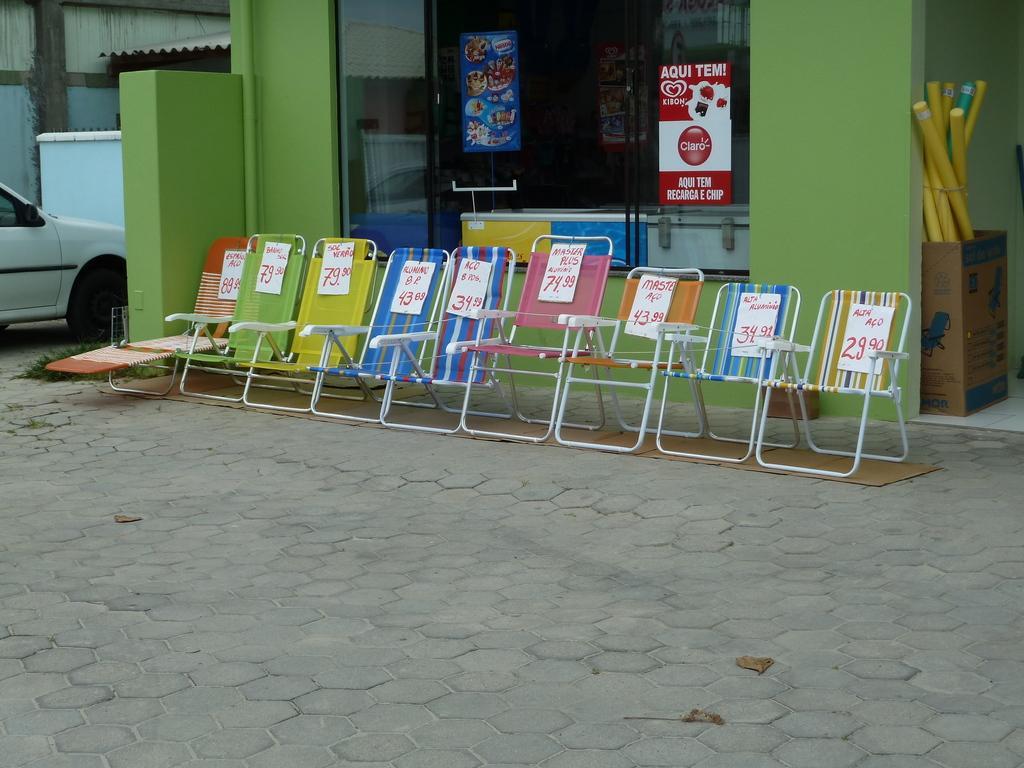How would you summarize this image in a sentence or two? In the image there are few chairs in front of a store with cardboard on the right side with some sticks in it, on the left side there is a car on the road. 